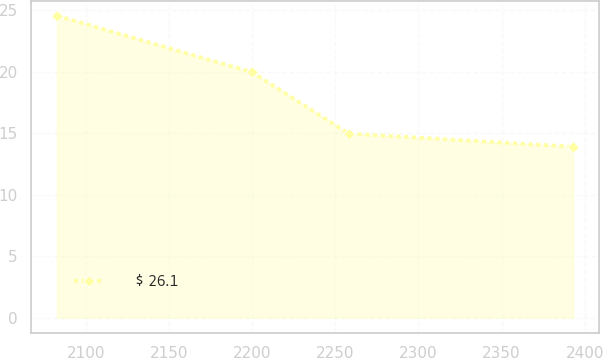Convert chart. <chart><loc_0><loc_0><loc_500><loc_500><line_chart><ecel><fcel>$ 26.1<nl><fcel>2082.53<fcel>24.57<nl><fcel>2199.75<fcel>19.98<nl><fcel>2258.01<fcel>14.98<nl><fcel>2393.02<fcel>13.91<nl></chart> 